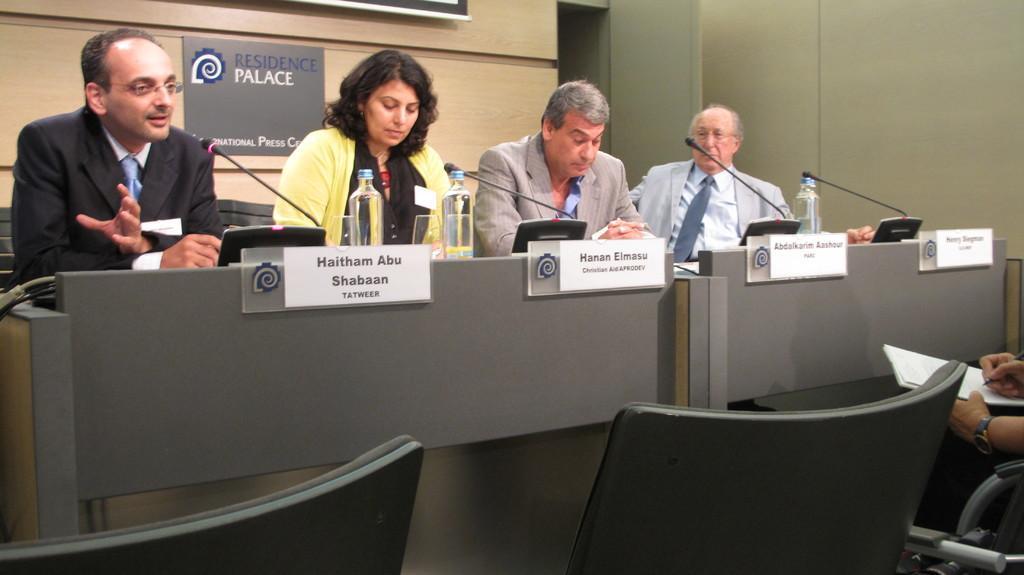In one or two sentences, can you explain what this image depicts? As we can see in the image there are few persons sitting on chairs. There are mice, bottles, posters and wall. The person sitting on the right side is holding book. 